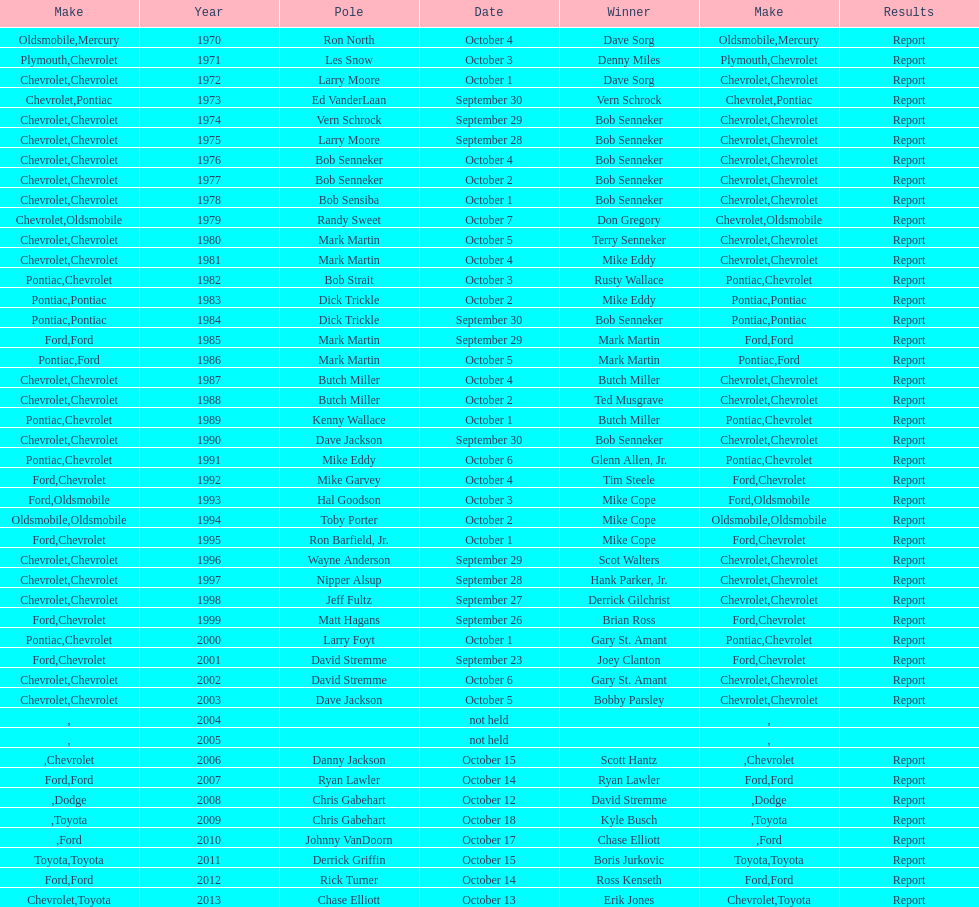Who on the list has the highest number of consecutive wins? Bob Senneker. 